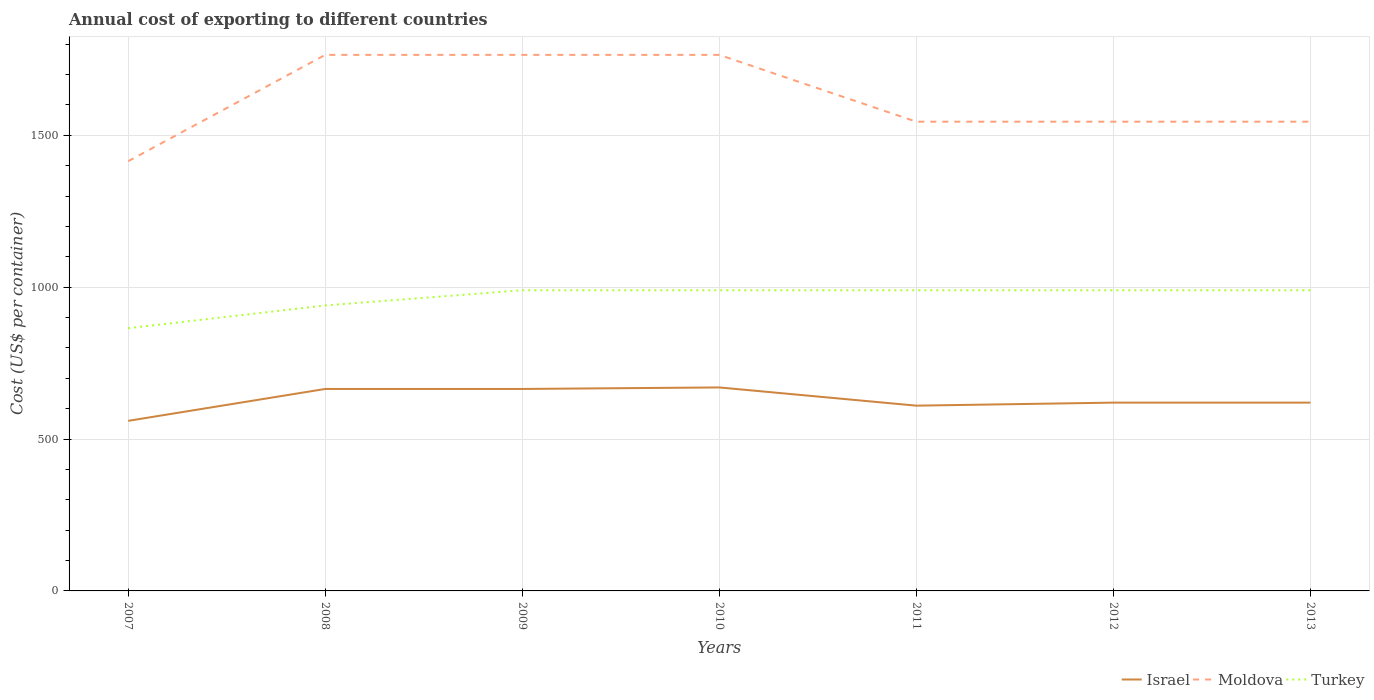How many different coloured lines are there?
Provide a succinct answer. 3. Is the number of lines equal to the number of legend labels?
Your answer should be very brief. Yes. Across all years, what is the maximum total annual cost of exporting in Turkey?
Give a very brief answer. 865. What is the total total annual cost of exporting in Turkey in the graph?
Offer a very short reply. -50. What is the difference between the highest and the second highest total annual cost of exporting in Turkey?
Make the answer very short. 125. Is the total annual cost of exporting in Turkey strictly greater than the total annual cost of exporting in Moldova over the years?
Your answer should be very brief. Yes. What is the difference between two consecutive major ticks on the Y-axis?
Your answer should be compact. 500. Are the values on the major ticks of Y-axis written in scientific E-notation?
Ensure brevity in your answer.  No. Does the graph contain grids?
Your answer should be compact. Yes. How many legend labels are there?
Keep it short and to the point. 3. What is the title of the graph?
Offer a terse response. Annual cost of exporting to different countries. Does "Faeroe Islands" appear as one of the legend labels in the graph?
Your answer should be compact. No. What is the label or title of the Y-axis?
Offer a very short reply. Cost (US$ per container). What is the Cost (US$ per container) in Israel in 2007?
Make the answer very short. 560. What is the Cost (US$ per container) of Moldova in 2007?
Your answer should be compact. 1415. What is the Cost (US$ per container) in Turkey in 2007?
Keep it short and to the point. 865. What is the Cost (US$ per container) of Israel in 2008?
Your answer should be very brief. 665. What is the Cost (US$ per container) in Moldova in 2008?
Your answer should be very brief. 1765. What is the Cost (US$ per container) in Turkey in 2008?
Your answer should be very brief. 940. What is the Cost (US$ per container) of Israel in 2009?
Keep it short and to the point. 665. What is the Cost (US$ per container) of Moldova in 2009?
Provide a succinct answer. 1765. What is the Cost (US$ per container) of Turkey in 2009?
Offer a terse response. 990. What is the Cost (US$ per container) of Israel in 2010?
Offer a very short reply. 670. What is the Cost (US$ per container) of Moldova in 2010?
Keep it short and to the point. 1765. What is the Cost (US$ per container) of Turkey in 2010?
Ensure brevity in your answer.  990. What is the Cost (US$ per container) of Israel in 2011?
Keep it short and to the point. 610. What is the Cost (US$ per container) in Moldova in 2011?
Your answer should be compact. 1545. What is the Cost (US$ per container) in Turkey in 2011?
Keep it short and to the point. 990. What is the Cost (US$ per container) of Israel in 2012?
Provide a succinct answer. 620. What is the Cost (US$ per container) in Moldova in 2012?
Your answer should be very brief. 1545. What is the Cost (US$ per container) of Turkey in 2012?
Offer a terse response. 990. What is the Cost (US$ per container) of Israel in 2013?
Keep it short and to the point. 620. What is the Cost (US$ per container) in Moldova in 2013?
Offer a terse response. 1545. What is the Cost (US$ per container) in Turkey in 2013?
Make the answer very short. 990. Across all years, what is the maximum Cost (US$ per container) of Israel?
Your answer should be compact. 670. Across all years, what is the maximum Cost (US$ per container) of Moldova?
Provide a succinct answer. 1765. Across all years, what is the maximum Cost (US$ per container) in Turkey?
Offer a terse response. 990. Across all years, what is the minimum Cost (US$ per container) of Israel?
Your answer should be very brief. 560. Across all years, what is the minimum Cost (US$ per container) of Moldova?
Offer a very short reply. 1415. Across all years, what is the minimum Cost (US$ per container) of Turkey?
Your response must be concise. 865. What is the total Cost (US$ per container) of Israel in the graph?
Keep it short and to the point. 4410. What is the total Cost (US$ per container) in Moldova in the graph?
Make the answer very short. 1.13e+04. What is the total Cost (US$ per container) in Turkey in the graph?
Make the answer very short. 6755. What is the difference between the Cost (US$ per container) of Israel in 2007 and that in 2008?
Your response must be concise. -105. What is the difference between the Cost (US$ per container) of Moldova in 2007 and that in 2008?
Your answer should be compact. -350. What is the difference between the Cost (US$ per container) in Turkey in 2007 and that in 2008?
Offer a terse response. -75. What is the difference between the Cost (US$ per container) in Israel in 2007 and that in 2009?
Give a very brief answer. -105. What is the difference between the Cost (US$ per container) of Moldova in 2007 and that in 2009?
Ensure brevity in your answer.  -350. What is the difference between the Cost (US$ per container) in Turkey in 2007 and that in 2009?
Keep it short and to the point. -125. What is the difference between the Cost (US$ per container) in Israel in 2007 and that in 2010?
Your response must be concise. -110. What is the difference between the Cost (US$ per container) of Moldova in 2007 and that in 2010?
Your response must be concise. -350. What is the difference between the Cost (US$ per container) in Turkey in 2007 and that in 2010?
Offer a very short reply. -125. What is the difference between the Cost (US$ per container) in Moldova in 2007 and that in 2011?
Give a very brief answer. -130. What is the difference between the Cost (US$ per container) in Turkey in 2007 and that in 2011?
Give a very brief answer. -125. What is the difference between the Cost (US$ per container) of Israel in 2007 and that in 2012?
Provide a short and direct response. -60. What is the difference between the Cost (US$ per container) in Moldova in 2007 and that in 2012?
Provide a short and direct response. -130. What is the difference between the Cost (US$ per container) of Turkey in 2007 and that in 2012?
Offer a very short reply. -125. What is the difference between the Cost (US$ per container) in Israel in 2007 and that in 2013?
Your answer should be compact. -60. What is the difference between the Cost (US$ per container) of Moldova in 2007 and that in 2013?
Make the answer very short. -130. What is the difference between the Cost (US$ per container) of Turkey in 2007 and that in 2013?
Offer a very short reply. -125. What is the difference between the Cost (US$ per container) in Moldova in 2008 and that in 2009?
Provide a succinct answer. 0. What is the difference between the Cost (US$ per container) in Turkey in 2008 and that in 2009?
Offer a very short reply. -50. What is the difference between the Cost (US$ per container) in Turkey in 2008 and that in 2010?
Ensure brevity in your answer.  -50. What is the difference between the Cost (US$ per container) in Israel in 2008 and that in 2011?
Provide a short and direct response. 55. What is the difference between the Cost (US$ per container) of Moldova in 2008 and that in 2011?
Ensure brevity in your answer.  220. What is the difference between the Cost (US$ per container) in Moldova in 2008 and that in 2012?
Offer a very short reply. 220. What is the difference between the Cost (US$ per container) of Moldova in 2008 and that in 2013?
Give a very brief answer. 220. What is the difference between the Cost (US$ per container) of Moldova in 2009 and that in 2010?
Keep it short and to the point. 0. What is the difference between the Cost (US$ per container) in Moldova in 2009 and that in 2011?
Your answer should be very brief. 220. What is the difference between the Cost (US$ per container) in Turkey in 2009 and that in 2011?
Provide a succinct answer. 0. What is the difference between the Cost (US$ per container) of Moldova in 2009 and that in 2012?
Provide a succinct answer. 220. What is the difference between the Cost (US$ per container) in Turkey in 2009 and that in 2012?
Provide a short and direct response. 0. What is the difference between the Cost (US$ per container) of Moldova in 2009 and that in 2013?
Offer a terse response. 220. What is the difference between the Cost (US$ per container) of Moldova in 2010 and that in 2011?
Provide a short and direct response. 220. What is the difference between the Cost (US$ per container) in Turkey in 2010 and that in 2011?
Give a very brief answer. 0. What is the difference between the Cost (US$ per container) of Israel in 2010 and that in 2012?
Keep it short and to the point. 50. What is the difference between the Cost (US$ per container) in Moldova in 2010 and that in 2012?
Offer a very short reply. 220. What is the difference between the Cost (US$ per container) of Israel in 2010 and that in 2013?
Your response must be concise. 50. What is the difference between the Cost (US$ per container) of Moldova in 2010 and that in 2013?
Give a very brief answer. 220. What is the difference between the Cost (US$ per container) in Turkey in 2010 and that in 2013?
Your answer should be compact. 0. What is the difference between the Cost (US$ per container) of Israel in 2011 and that in 2012?
Keep it short and to the point. -10. What is the difference between the Cost (US$ per container) of Turkey in 2011 and that in 2012?
Keep it short and to the point. 0. What is the difference between the Cost (US$ per container) of Israel in 2011 and that in 2013?
Provide a succinct answer. -10. What is the difference between the Cost (US$ per container) of Moldova in 2012 and that in 2013?
Offer a terse response. 0. What is the difference between the Cost (US$ per container) in Turkey in 2012 and that in 2013?
Offer a very short reply. 0. What is the difference between the Cost (US$ per container) in Israel in 2007 and the Cost (US$ per container) in Moldova in 2008?
Your answer should be compact. -1205. What is the difference between the Cost (US$ per container) in Israel in 2007 and the Cost (US$ per container) in Turkey in 2008?
Give a very brief answer. -380. What is the difference between the Cost (US$ per container) in Moldova in 2007 and the Cost (US$ per container) in Turkey in 2008?
Your answer should be very brief. 475. What is the difference between the Cost (US$ per container) in Israel in 2007 and the Cost (US$ per container) in Moldova in 2009?
Your answer should be compact. -1205. What is the difference between the Cost (US$ per container) in Israel in 2007 and the Cost (US$ per container) in Turkey in 2009?
Provide a succinct answer. -430. What is the difference between the Cost (US$ per container) in Moldova in 2007 and the Cost (US$ per container) in Turkey in 2009?
Ensure brevity in your answer.  425. What is the difference between the Cost (US$ per container) in Israel in 2007 and the Cost (US$ per container) in Moldova in 2010?
Provide a short and direct response. -1205. What is the difference between the Cost (US$ per container) in Israel in 2007 and the Cost (US$ per container) in Turkey in 2010?
Give a very brief answer. -430. What is the difference between the Cost (US$ per container) of Moldova in 2007 and the Cost (US$ per container) of Turkey in 2010?
Your answer should be compact. 425. What is the difference between the Cost (US$ per container) of Israel in 2007 and the Cost (US$ per container) of Moldova in 2011?
Ensure brevity in your answer.  -985. What is the difference between the Cost (US$ per container) in Israel in 2007 and the Cost (US$ per container) in Turkey in 2011?
Provide a short and direct response. -430. What is the difference between the Cost (US$ per container) in Moldova in 2007 and the Cost (US$ per container) in Turkey in 2011?
Provide a succinct answer. 425. What is the difference between the Cost (US$ per container) in Israel in 2007 and the Cost (US$ per container) in Moldova in 2012?
Your response must be concise. -985. What is the difference between the Cost (US$ per container) in Israel in 2007 and the Cost (US$ per container) in Turkey in 2012?
Your answer should be very brief. -430. What is the difference between the Cost (US$ per container) in Moldova in 2007 and the Cost (US$ per container) in Turkey in 2012?
Provide a short and direct response. 425. What is the difference between the Cost (US$ per container) in Israel in 2007 and the Cost (US$ per container) in Moldova in 2013?
Provide a short and direct response. -985. What is the difference between the Cost (US$ per container) of Israel in 2007 and the Cost (US$ per container) of Turkey in 2013?
Provide a succinct answer. -430. What is the difference between the Cost (US$ per container) of Moldova in 2007 and the Cost (US$ per container) of Turkey in 2013?
Keep it short and to the point. 425. What is the difference between the Cost (US$ per container) in Israel in 2008 and the Cost (US$ per container) in Moldova in 2009?
Your response must be concise. -1100. What is the difference between the Cost (US$ per container) in Israel in 2008 and the Cost (US$ per container) in Turkey in 2009?
Ensure brevity in your answer.  -325. What is the difference between the Cost (US$ per container) of Moldova in 2008 and the Cost (US$ per container) of Turkey in 2009?
Provide a succinct answer. 775. What is the difference between the Cost (US$ per container) of Israel in 2008 and the Cost (US$ per container) of Moldova in 2010?
Ensure brevity in your answer.  -1100. What is the difference between the Cost (US$ per container) of Israel in 2008 and the Cost (US$ per container) of Turkey in 2010?
Give a very brief answer. -325. What is the difference between the Cost (US$ per container) in Moldova in 2008 and the Cost (US$ per container) in Turkey in 2010?
Keep it short and to the point. 775. What is the difference between the Cost (US$ per container) of Israel in 2008 and the Cost (US$ per container) of Moldova in 2011?
Provide a succinct answer. -880. What is the difference between the Cost (US$ per container) in Israel in 2008 and the Cost (US$ per container) in Turkey in 2011?
Make the answer very short. -325. What is the difference between the Cost (US$ per container) of Moldova in 2008 and the Cost (US$ per container) of Turkey in 2011?
Offer a terse response. 775. What is the difference between the Cost (US$ per container) in Israel in 2008 and the Cost (US$ per container) in Moldova in 2012?
Offer a very short reply. -880. What is the difference between the Cost (US$ per container) of Israel in 2008 and the Cost (US$ per container) of Turkey in 2012?
Give a very brief answer. -325. What is the difference between the Cost (US$ per container) of Moldova in 2008 and the Cost (US$ per container) of Turkey in 2012?
Your response must be concise. 775. What is the difference between the Cost (US$ per container) of Israel in 2008 and the Cost (US$ per container) of Moldova in 2013?
Your answer should be very brief. -880. What is the difference between the Cost (US$ per container) of Israel in 2008 and the Cost (US$ per container) of Turkey in 2013?
Keep it short and to the point. -325. What is the difference between the Cost (US$ per container) in Moldova in 2008 and the Cost (US$ per container) in Turkey in 2013?
Offer a very short reply. 775. What is the difference between the Cost (US$ per container) in Israel in 2009 and the Cost (US$ per container) in Moldova in 2010?
Make the answer very short. -1100. What is the difference between the Cost (US$ per container) in Israel in 2009 and the Cost (US$ per container) in Turkey in 2010?
Your response must be concise. -325. What is the difference between the Cost (US$ per container) of Moldova in 2009 and the Cost (US$ per container) of Turkey in 2010?
Offer a terse response. 775. What is the difference between the Cost (US$ per container) in Israel in 2009 and the Cost (US$ per container) in Moldova in 2011?
Make the answer very short. -880. What is the difference between the Cost (US$ per container) in Israel in 2009 and the Cost (US$ per container) in Turkey in 2011?
Offer a very short reply. -325. What is the difference between the Cost (US$ per container) in Moldova in 2009 and the Cost (US$ per container) in Turkey in 2011?
Ensure brevity in your answer.  775. What is the difference between the Cost (US$ per container) of Israel in 2009 and the Cost (US$ per container) of Moldova in 2012?
Your response must be concise. -880. What is the difference between the Cost (US$ per container) in Israel in 2009 and the Cost (US$ per container) in Turkey in 2012?
Make the answer very short. -325. What is the difference between the Cost (US$ per container) of Moldova in 2009 and the Cost (US$ per container) of Turkey in 2012?
Offer a very short reply. 775. What is the difference between the Cost (US$ per container) in Israel in 2009 and the Cost (US$ per container) in Moldova in 2013?
Keep it short and to the point. -880. What is the difference between the Cost (US$ per container) of Israel in 2009 and the Cost (US$ per container) of Turkey in 2013?
Provide a short and direct response. -325. What is the difference between the Cost (US$ per container) in Moldova in 2009 and the Cost (US$ per container) in Turkey in 2013?
Give a very brief answer. 775. What is the difference between the Cost (US$ per container) of Israel in 2010 and the Cost (US$ per container) of Moldova in 2011?
Your response must be concise. -875. What is the difference between the Cost (US$ per container) in Israel in 2010 and the Cost (US$ per container) in Turkey in 2011?
Provide a short and direct response. -320. What is the difference between the Cost (US$ per container) of Moldova in 2010 and the Cost (US$ per container) of Turkey in 2011?
Make the answer very short. 775. What is the difference between the Cost (US$ per container) of Israel in 2010 and the Cost (US$ per container) of Moldova in 2012?
Provide a short and direct response. -875. What is the difference between the Cost (US$ per container) of Israel in 2010 and the Cost (US$ per container) of Turkey in 2012?
Offer a very short reply. -320. What is the difference between the Cost (US$ per container) of Moldova in 2010 and the Cost (US$ per container) of Turkey in 2012?
Make the answer very short. 775. What is the difference between the Cost (US$ per container) in Israel in 2010 and the Cost (US$ per container) in Moldova in 2013?
Give a very brief answer. -875. What is the difference between the Cost (US$ per container) of Israel in 2010 and the Cost (US$ per container) of Turkey in 2013?
Ensure brevity in your answer.  -320. What is the difference between the Cost (US$ per container) in Moldova in 2010 and the Cost (US$ per container) in Turkey in 2013?
Your answer should be compact. 775. What is the difference between the Cost (US$ per container) in Israel in 2011 and the Cost (US$ per container) in Moldova in 2012?
Make the answer very short. -935. What is the difference between the Cost (US$ per container) of Israel in 2011 and the Cost (US$ per container) of Turkey in 2012?
Give a very brief answer. -380. What is the difference between the Cost (US$ per container) in Moldova in 2011 and the Cost (US$ per container) in Turkey in 2012?
Offer a very short reply. 555. What is the difference between the Cost (US$ per container) in Israel in 2011 and the Cost (US$ per container) in Moldova in 2013?
Keep it short and to the point. -935. What is the difference between the Cost (US$ per container) in Israel in 2011 and the Cost (US$ per container) in Turkey in 2013?
Your answer should be very brief. -380. What is the difference between the Cost (US$ per container) in Moldova in 2011 and the Cost (US$ per container) in Turkey in 2013?
Provide a short and direct response. 555. What is the difference between the Cost (US$ per container) of Israel in 2012 and the Cost (US$ per container) of Moldova in 2013?
Offer a terse response. -925. What is the difference between the Cost (US$ per container) in Israel in 2012 and the Cost (US$ per container) in Turkey in 2013?
Make the answer very short. -370. What is the difference between the Cost (US$ per container) in Moldova in 2012 and the Cost (US$ per container) in Turkey in 2013?
Offer a terse response. 555. What is the average Cost (US$ per container) in Israel per year?
Ensure brevity in your answer.  630. What is the average Cost (US$ per container) in Moldova per year?
Provide a succinct answer. 1620.71. What is the average Cost (US$ per container) in Turkey per year?
Your response must be concise. 965. In the year 2007, what is the difference between the Cost (US$ per container) of Israel and Cost (US$ per container) of Moldova?
Your answer should be compact. -855. In the year 2007, what is the difference between the Cost (US$ per container) of Israel and Cost (US$ per container) of Turkey?
Offer a very short reply. -305. In the year 2007, what is the difference between the Cost (US$ per container) in Moldova and Cost (US$ per container) in Turkey?
Provide a succinct answer. 550. In the year 2008, what is the difference between the Cost (US$ per container) of Israel and Cost (US$ per container) of Moldova?
Make the answer very short. -1100. In the year 2008, what is the difference between the Cost (US$ per container) of Israel and Cost (US$ per container) of Turkey?
Provide a short and direct response. -275. In the year 2008, what is the difference between the Cost (US$ per container) of Moldova and Cost (US$ per container) of Turkey?
Give a very brief answer. 825. In the year 2009, what is the difference between the Cost (US$ per container) of Israel and Cost (US$ per container) of Moldova?
Offer a very short reply. -1100. In the year 2009, what is the difference between the Cost (US$ per container) in Israel and Cost (US$ per container) in Turkey?
Give a very brief answer. -325. In the year 2009, what is the difference between the Cost (US$ per container) of Moldova and Cost (US$ per container) of Turkey?
Make the answer very short. 775. In the year 2010, what is the difference between the Cost (US$ per container) in Israel and Cost (US$ per container) in Moldova?
Your answer should be compact. -1095. In the year 2010, what is the difference between the Cost (US$ per container) of Israel and Cost (US$ per container) of Turkey?
Make the answer very short. -320. In the year 2010, what is the difference between the Cost (US$ per container) in Moldova and Cost (US$ per container) in Turkey?
Your response must be concise. 775. In the year 2011, what is the difference between the Cost (US$ per container) in Israel and Cost (US$ per container) in Moldova?
Ensure brevity in your answer.  -935. In the year 2011, what is the difference between the Cost (US$ per container) of Israel and Cost (US$ per container) of Turkey?
Provide a succinct answer. -380. In the year 2011, what is the difference between the Cost (US$ per container) of Moldova and Cost (US$ per container) of Turkey?
Your response must be concise. 555. In the year 2012, what is the difference between the Cost (US$ per container) of Israel and Cost (US$ per container) of Moldova?
Your response must be concise. -925. In the year 2012, what is the difference between the Cost (US$ per container) in Israel and Cost (US$ per container) in Turkey?
Keep it short and to the point. -370. In the year 2012, what is the difference between the Cost (US$ per container) in Moldova and Cost (US$ per container) in Turkey?
Offer a very short reply. 555. In the year 2013, what is the difference between the Cost (US$ per container) in Israel and Cost (US$ per container) in Moldova?
Give a very brief answer. -925. In the year 2013, what is the difference between the Cost (US$ per container) in Israel and Cost (US$ per container) in Turkey?
Your response must be concise. -370. In the year 2013, what is the difference between the Cost (US$ per container) of Moldova and Cost (US$ per container) of Turkey?
Provide a succinct answer. 555. What is the ratio of the Cost (US$ per container) in Israel in 2007 to that in 2008?
Keep it short and to the point. 0.84. What is the ratio of the Cost (US$ per container) in Moldova in 2007 to that in 2008?
Offer a terse response. 0.8. What is the ratio of the Cost (US$ per container) of Turkey in 2007 to that in 2008?
Keep it short and to the point. 0.92. What is the ratio of the Cost (US$ per container) of Israel in 2007 to that in 2009?
Your answer should be compact. 0.84. What is the ratio of the Cost (US$ per container) of Moldova in 2007 to that in 2009?
Your answer should be compact. 0.8. What is the ratio of the Cost (US$ per container) of Turkey in 2007 to that in 2009?
Your response must be concise. 0.87. What is the ratio of the Cost (US$ per container) of Israel in 2007 to that in 2010?
Offer a very short reply. 0.84. What is the ratio of the Cost (US$ per container) of Moldova in 2007 to that in 2010?
Your response must be concise. 0.8. What is the ratio of the Cost (US$ per container) of Turkey in 2007 to that in 2010?
Your answer should be compact. 0.87. What is the ratio of the Cost (US$ per container) in Israel in 2007 to that in 2011?
Offer a very short reply. 0.92. What is the ratio of the Cost (US$ per container) in Moldova in 2007 to that in 2011?
Provide a short and direct response. 0.92. What is the ratio of the Cost (US$ per container) in Turkey in 2007 to that in 2011?
Make the answer very short. 0.87. What is the ratio of the Cost (US$ per container) of Israel in 2007 to that in 2012?
Provide a succinct answer. 0.9. What is the ratio of the Cost (US$ per container) in Moldova in 2007 to that in 2012?
Your answer should be compact. 0.92. What is the ratio of the Cost (US$ per container) of Turkey in 2007 to that in 2012?
Make the answer very short. 0.87. What is the ratio of the Cost (US$ per container) in Israel in 2007 to that in 2013?
Ensure brevity in your answer.  0.9. What is the ratio of the Cost (US$ per container) of Moldova in 2007 to that in 2013?
Your answer should be very brief. 0.92. What is the ratio of the Cost (US$ per container) of Turkey in 2007 to that in 2013?
Make the answer very short. 0.87. What is the ratio of the Cost (US$ per container) of Israel in 2008 to that in 2009?
Offer a very short reply. 1. What is the ratio of the Cost (US$ per container) of Turkey in 2008 to that in 2009?
Offer a very short reply. 0.95. What is the ratio of the Cost (US$ per container) in Israel in 2008 to that in 2010?
Keep it short and to the point. 0.99. What is the ratio of the Cost (US$ per container) in Moldova in 2008 to that in 2010?
Make the answer very short. 1. What is the ratio of the Cost (US$ per container) in Turkey in 2008 to that in 2010?
Provide a short and direct response. 0.95. What is the ratio of the Cost (US$ per container) in Israel in 2008 to that in 2011?
Your answer should be compact. 1.09. What is the ratio of the Cost (US$ per container) of Moldova in 2008 to that in 2011?
Give a very brief answer. 1.14. What is the ratio of the Cost (US$ per container) of Turkey in 2008 to that in 2011?
Provide a short and direct response. 0.95. What is the ratio of the Cost (US$ per container) in Israel in 2008 to that in 2012?
Give a very brief answer. 1.07. What is the ratio of the Cost (US$ per container) of Moldova in 2008 to that in 2012?
Your answer should be very brief. 1.14. What is the ratio of the Cost (US$ per container) of Turkey in 2008 to that in 2012?
Provide a succinct answer. 0.95. What is the ratio of the Cost (US$ per container) in Israel in 2008 to that in 2013?
Your response must be concise. 1.07. What is the ratio of the Cost (US$ per container) of Moldova in 2008 to that in 2013?
Provide a succinct answer. 1.14. What is the ratio of the Cost (US$ per container) of Turkey in 2008 to that in 2013?
Make the answer very short. 0.95. What is the ratio of the Cost (US$ per container) of Moldova in 2009 to that in 2010?
Ensure brevity in your answer.  1. What is the ratio of the Cost (US$ per container) in Turkey in 2009 to that in 2010?
Ensure brevity in your answer.  1. What is the ratio of the Cost (US$ per container) of Israel in 2009 to that in 2011?
Provide a short and direct response. 1.09. What is the ratio of the Cost (US$ per container) of Moldova in 2009 to that in 2011?
Offer a terse response. 1.14. What is the ratio of the Cost (US$ per container) in Israel in 2009 to that in 2012?
Offer a very short reply. 1.07. What is the ratio of the Cost (US$ per container) in Moldova in 2009 to that in 2012?
Provide a succinct answer. 1.14. What is the ratio of the Cost (US$ per container) of Turkey in 2009 to that in 2012?
Offer a very short reply. 1. What is the ratio of the Cost (US$ per container) of Israel in 2009 to that in 2013?
Offer a very short reply. 1.07. What is the ratio of the Cost (US$ per container) of Moldova in 2009 to that in 2013?
Make the answer very short. 1.14. What is the ratio of the Cost (US$ per container) of Turkey in 2009 to that in 2013?
Keep it short and to the point. 1. What is the ratio of the Cost (US$ per container) in Israel in 2010 to that in 2011?
Your answer should be compact. 1.1. What is the ratio of the Cost (US$ per container) in Moldova in 2010 to that in 2011?
Provide a succinct answer. 1.14. What is the ratio of the Cost (US$ per container) of Israel in 2010 to that in 2012?
Make the answer very short. 1.08. What is the ratio of the Cost (US$ per container) of Moldova in 2010 to that in 2012?
Your answer should be very brief. 1.14. What is the ratio of the Cost (US$ per container) of Israel in 2010 to that in 2013?
Keep it short and to the point. 1.08. What is the ratio of the Cost (US$ per container) in Moldova in 2010 to that in 2013?
Provide a succinct answer. 1.14. What is the ratio of the Cost (US$ per container) of Turkey in 2010 to that in 2013?
Your answer should be very brief. 1. What is the ratio of the Cost (US$ per container) in Israel in 2011 to that in 2012?
Provide a short and direct response. 0.98. What is the ratio of the Cost (US$ per container) of Israel in 2011 to that in 2013?
Provide a short and direct response. 0.98. What is the ratio of the Cost (US$ per container) of Israel in 2012 to that in 2013?
Give a very brief answer. 1. What is the ratio of the Cost (US$ per container) in Moldova in 2012 to that in 2013?
Your answer should be compact. 1. What is the ratio of the Cost (US$ per container) of Turkey in 2012 to that in 2013?
Provide a succinct answer. 1. What is the difference between the highest and the second highest Cost (US$ per container) of Moldova?
Give a very brief answer. 0. What is the difference between the highest and the lowest Cost (US$ per container) of Israel?
Your answer should be compact. 110. What is the difference between the highest and the lowest Cost (US$ per container) of Moldova?
Ensure brevity in your answer.  350. What is the difference between the highest and the lowest Cost (US$ per container) of Turkey?
Your response must be concise. 125. 